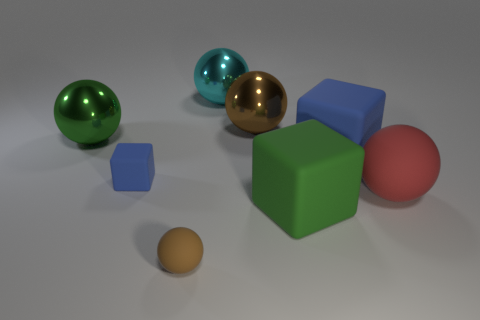Are there any large brown metallic objects that are on the right side of the blue cube that is right of the brown object that is to the right of the big cyan ball? no 